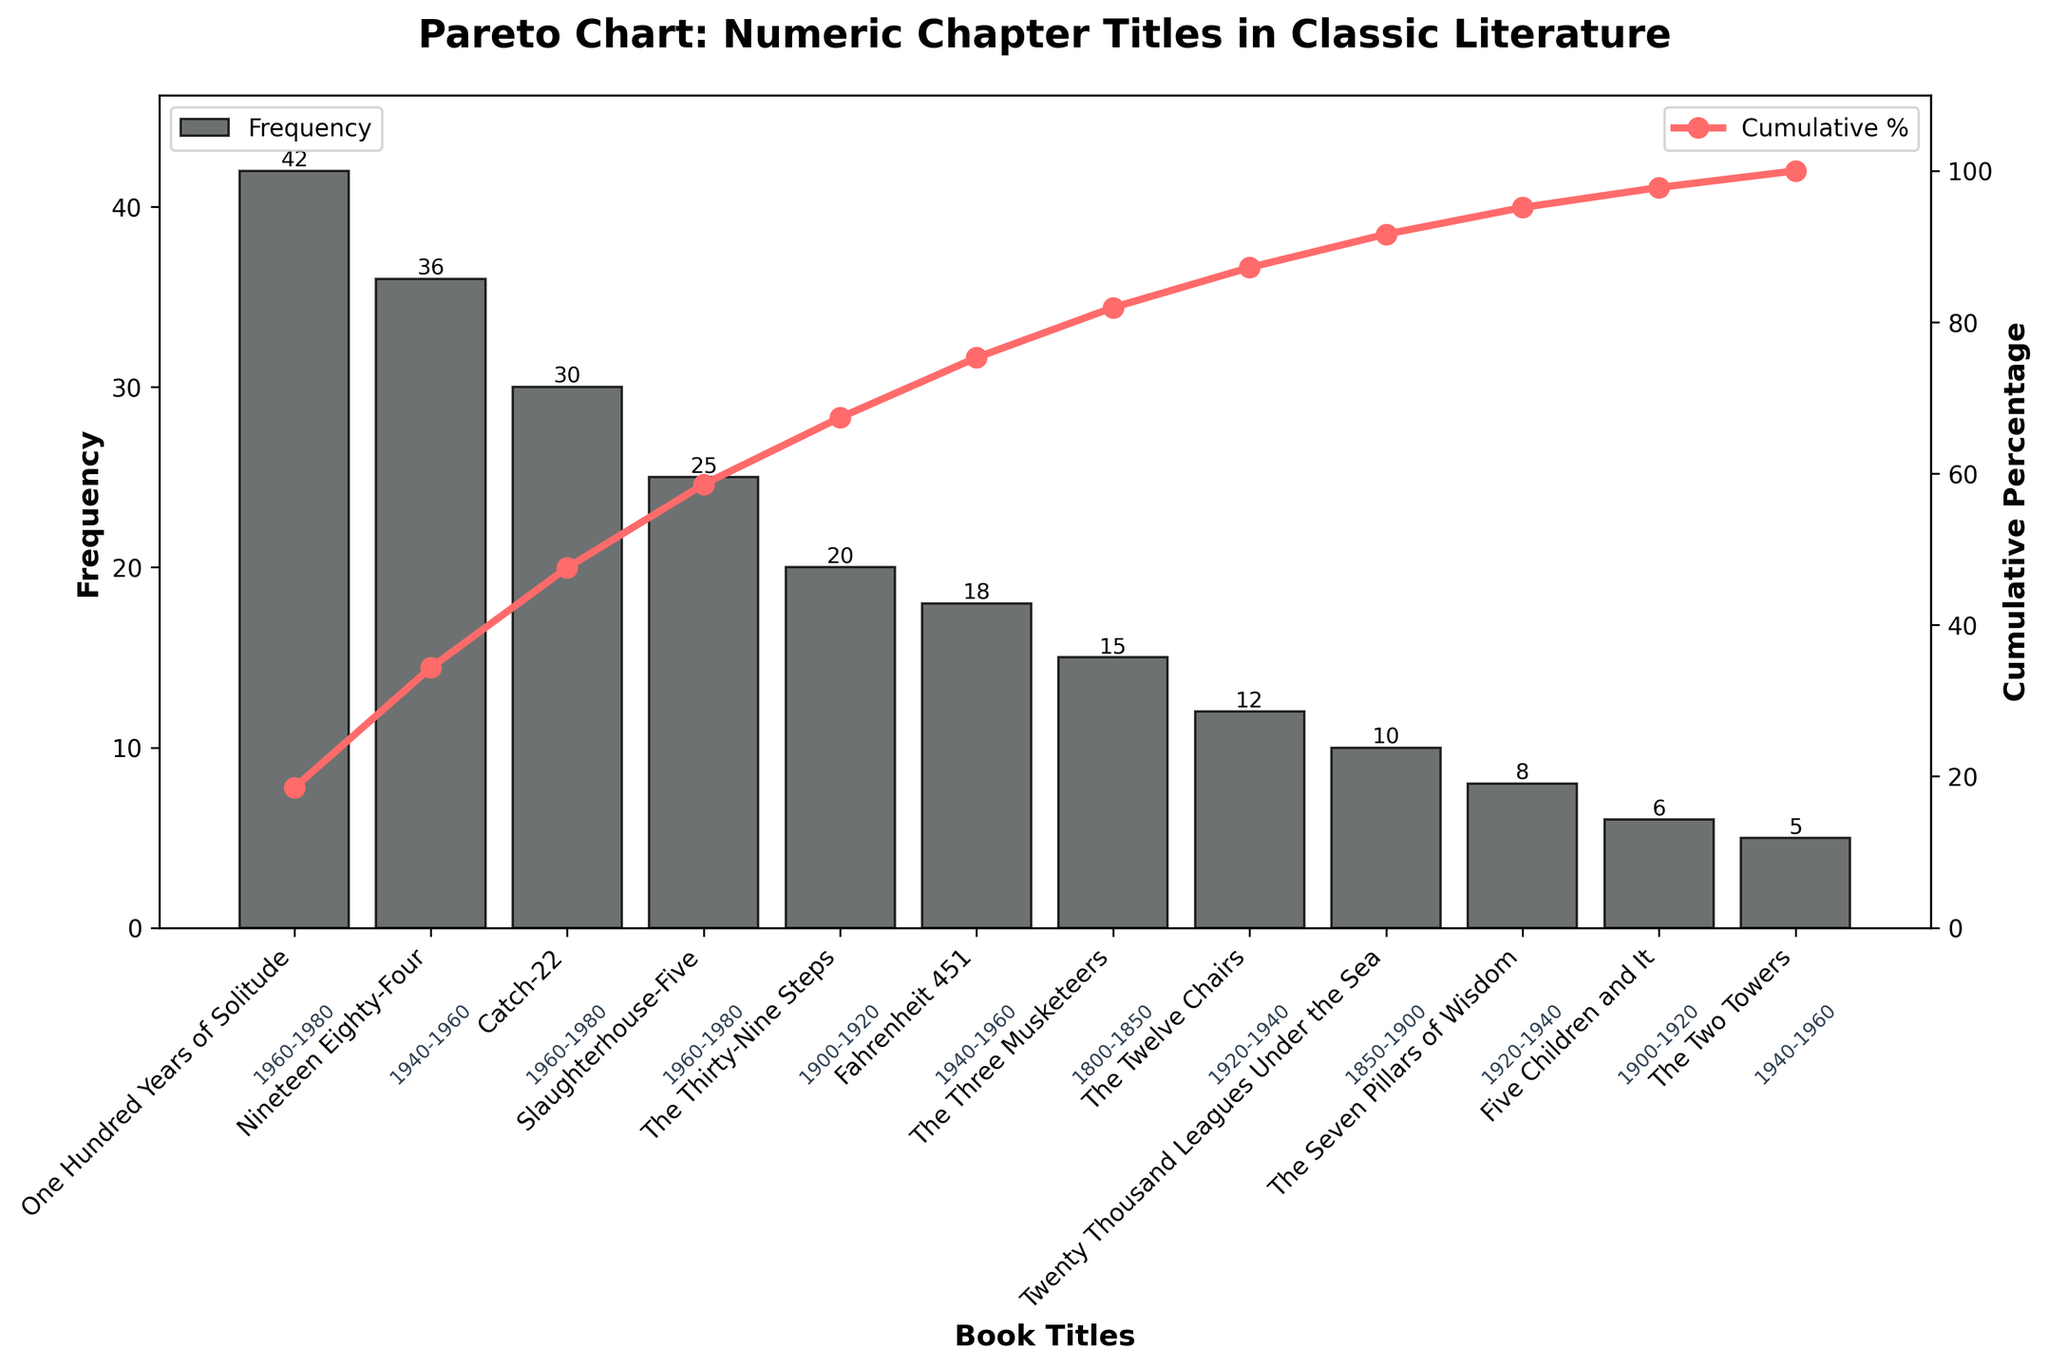What's the title of the chart? The title is displayed at the top of the figure. It reads "Pareto Chart: Numeric Chapter Titles in Classic Literature".
Answer: Pareto Chart: Numeric Chapter Titles in Classic Literature How many books are represented in the chart? Each bar in the chart represents one book. Counting the bars reveals there are 12 books.
Answer: 12 Which book has the highest frequency? The height of each bar indicates the frequency. The tallest bar belongs to "One Hundred Years of Solitude".
Answer: One Hundred Years of Solitude What percentage of the total does "Nineteen Eighty-Four" contribute? The cumulative percentage line indicates this. "Nineteen Eighty-Four" is the second bar, corresponding to 36 frequencies out of a total of 227. So, 36 / 227 * 100 = ~15.9%.
Answer: ~15.9% What is the cumulative percentage of the top three books? Sum the frequencies of "One Hundred Years of Solitude", "Nineteen Eighty-Four", and "Catch-22" (42, 36, 30). Their cumulative percentage is shown at the point in the line graph above the third bar. (42 + 36 + 30) / 227 * 100 = ~47.1%.
Answer: ~47.1% Which time period has the most books listed? By noting the annotations at the bottom of each bar. The 1960-1980 period has the most books: "One Hundred Years of Solitude", "Catch-22", and "Slaughterhouse-Five".
Answer: 1960-1980 How does "The Thirty-Nine Steps" compare to "The Twelve Chairs" in terms of frequency? "The Thirty-Nine Steps" frequency is 20, while "The Twelve Chairs" is 12. Since 20 > 12, "The Thirty-Nine Steps" has a higher frequency.
Answer: 20 > 12 What is the frequency of the book with the lowest count? The shortest bar represents "The Two Towers," with a frequency of 5.
Answer: 5 What is the frequency sum of books in the 1940-1960 period? The books from this period are "Nineteen Eighty-Four" (36), "Fahrenheit 451" (18), and "The Two Towers" (5). Summing these gives 36 + 18 + 5 = 59.
Answer: 59 Which book marks the point where the cumulative percentage first exceeds 75%? By following the cumulative percentage line until it surpasses 75%, it does so between "Slaughterhouse-Five" and "The Thirty-Nine Steps". Summing frequencies up to "Slaughterhouse-Five" (42 + 36 + 30 + 25 = 133), and (133 / 227 * 100 ~ 58.6%), we need "The Thirty-Nine Steps" to exceed 75%. So, "The Thirty-Nine Steps" marks this point as (42 + 36 + 30 + 25 + 20 = 153), (153 / 227 * 100 ~ 67.4%) and adding the next book "Fahrenheit 451" (42 + 36 + 30 + 25 + 20 + 18 = 171), (171 / 227 * 100 ~ 75.3%) meets the condition.
Answer: "Fahrenheit 451" What time period does "Twenty Thousand Leagues Under the Sea" belong to? The annotation beneath the bar for "Twenty Thousand Leagues Under the Sea" indicates the time period, which is 1850-1900.
Answer: 1850-1900 